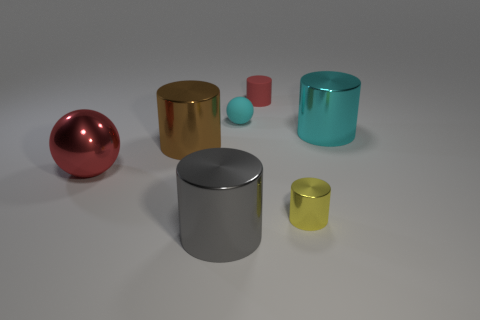Subtract all brown cylinders. How many cylinders are left? 4 Subtract all yellow cylinders. How many cylinders are left? 4 Add 2 big red cubes. How many objects exist? 9 Subtract all yellow cylinders. Subtract all brown spheres. How many cylinders are left? 4 Subtract all cylinders. How many objects are left? 2 Subtract 1 red cylinders. How many objects are left? 6 Subtract all large purple cylinders. Subtract all small metal things. How many objects are left? 6 Add 2 small cylinders. How many small cylinders are left? 4 Add 2 red things. How many red things exist? 4 